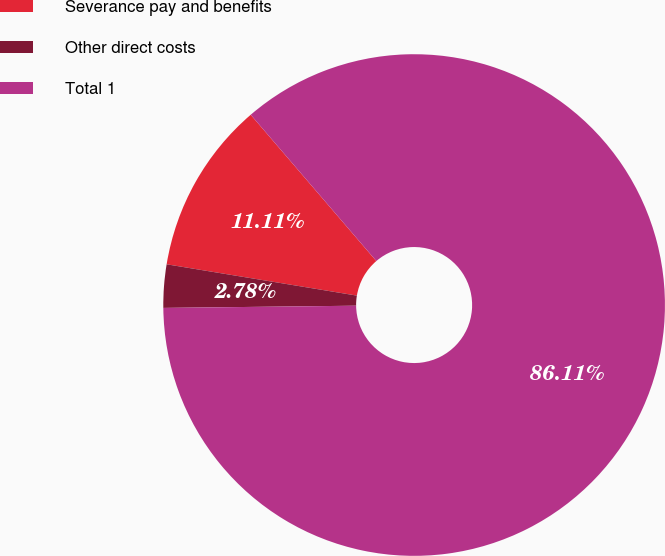Convert chart. <chart><loc_0><loc_0><loc_500><loc_500><pie_chart><fcel>Severance pay and benefits<fcel>Other direct costs<fcel>Total 1<nl><fcel>11.11%<fcel>2.78%<fcel>86.11%<nl></chart> 